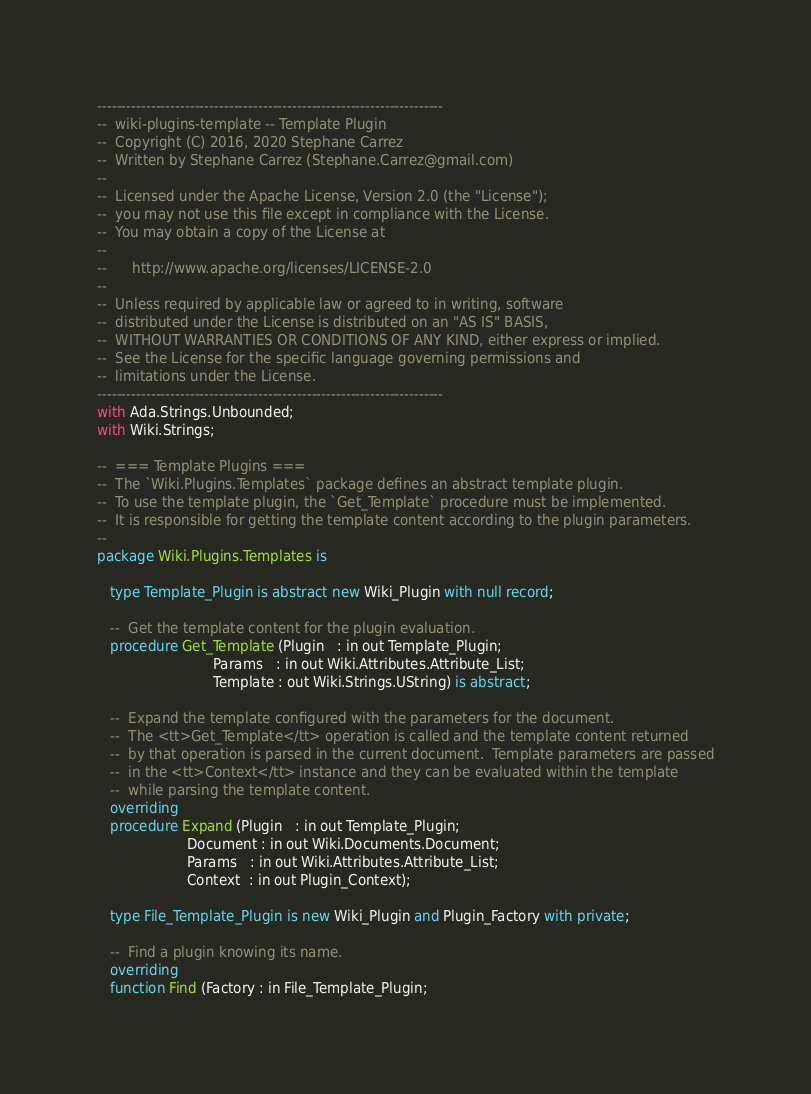<code> <loc_0><loc_0><loc_500><loc_500><_Ada_>-----------------------------------------------------------------------
--  wiki-plugins-template -- Template Plugin
--  Copyright (C) 2016, 2020 Stephane Carrez
--  Written by Stephane Carrez (Stephane.Carrez@gmail.com)
--
--  Licensed under the Apache License, Version 2.0 (the "License");
--  you may not use this file except in compliance with the License.
--  You may obtain a copy of the License at
--
--      http://www.apache.org/licenses/LICENSE-2.0
--
--  Unless required by applicable law or agreed to in writing, software
--  distributed under the License is distributed on an "AS IS" BASIS,
--  WITHOUT WARRANTIES OR CONDITIONS OF ANY KIND, either express or implied.
--  See the License for the specific language governing permissions and
--  limitations under the License.
-----------------------------------------------------------------------
with Ada.Strings.Unbounded;
with Wiki.Strings;

--  === Template Plugins ===
--  The `Wiki.Plugins.Templates` package defines an abstract template plugin.
--  To use the template plugin, the `Get_Template` procedure must be implemented.
--  It is responsible for getting the template content according to the plugin parameters.
--
package Wiki.Plugins.Templates is

   type Template_Plugin is abstract new Wiki_Plugin with null record;

   --  Get the template content for the plugin evaluation.
   procedure Get_Template (Plugin   : in out Template_Plugin;
                           Params   : in out Wiki.Attributes.Attribute_List;
                           Template : out Wiki.Strings.UString) is abstract;

   --  Expand the template configured with the parameters for the document.
   --  The <tt>Get_Template</tt> operation is called and the template content returned
   --  by that operation is parsed in the current document.  Template parameters are passed
   --  in the <tt>Context</tt> instance and they can be evaluated within the template
   --  while parsing the template content.
   overriding
   procedure Expand (Plugin   : in out Template_Plugin;
                     Document : in out Wiki.Documents.Document;
                     Params   : in out Wiki.Attributes.Attribute_List;
                     Context  : in out Plugin_Context);

   type File_Template_Plugin is new Wiki_Plugin and Plugin_Factory with private;

   --  Find a plugin knowing its name.
   overriding
   function Find (Factory : in File_Template_Plugin;</code> 